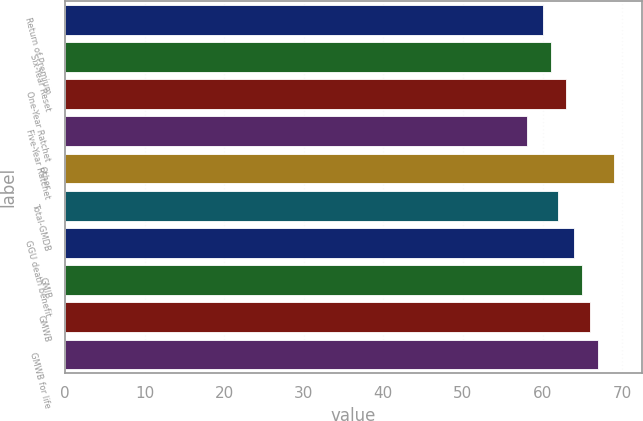Convert chart. <chart><loc_0><loc_0><loc_500><loc_500><bar_chart><fcel>Return of Premium<fcel>Six-Year Reset<fcel>One-Year Ratchet<fcel>Five-Year Ratchet<fcel>Other<fcel>Total-GMDB<fcel>GGU death benefit<fcel>GMIB<fcel>GMWB<fcel>GMWB for life<nl><fcel>60<fcel>61<fcel>63<fcel>58<fcel>69<fcel>62<fcel>64<fcel>65<fcel>66<fcel>67<nl></chart> 